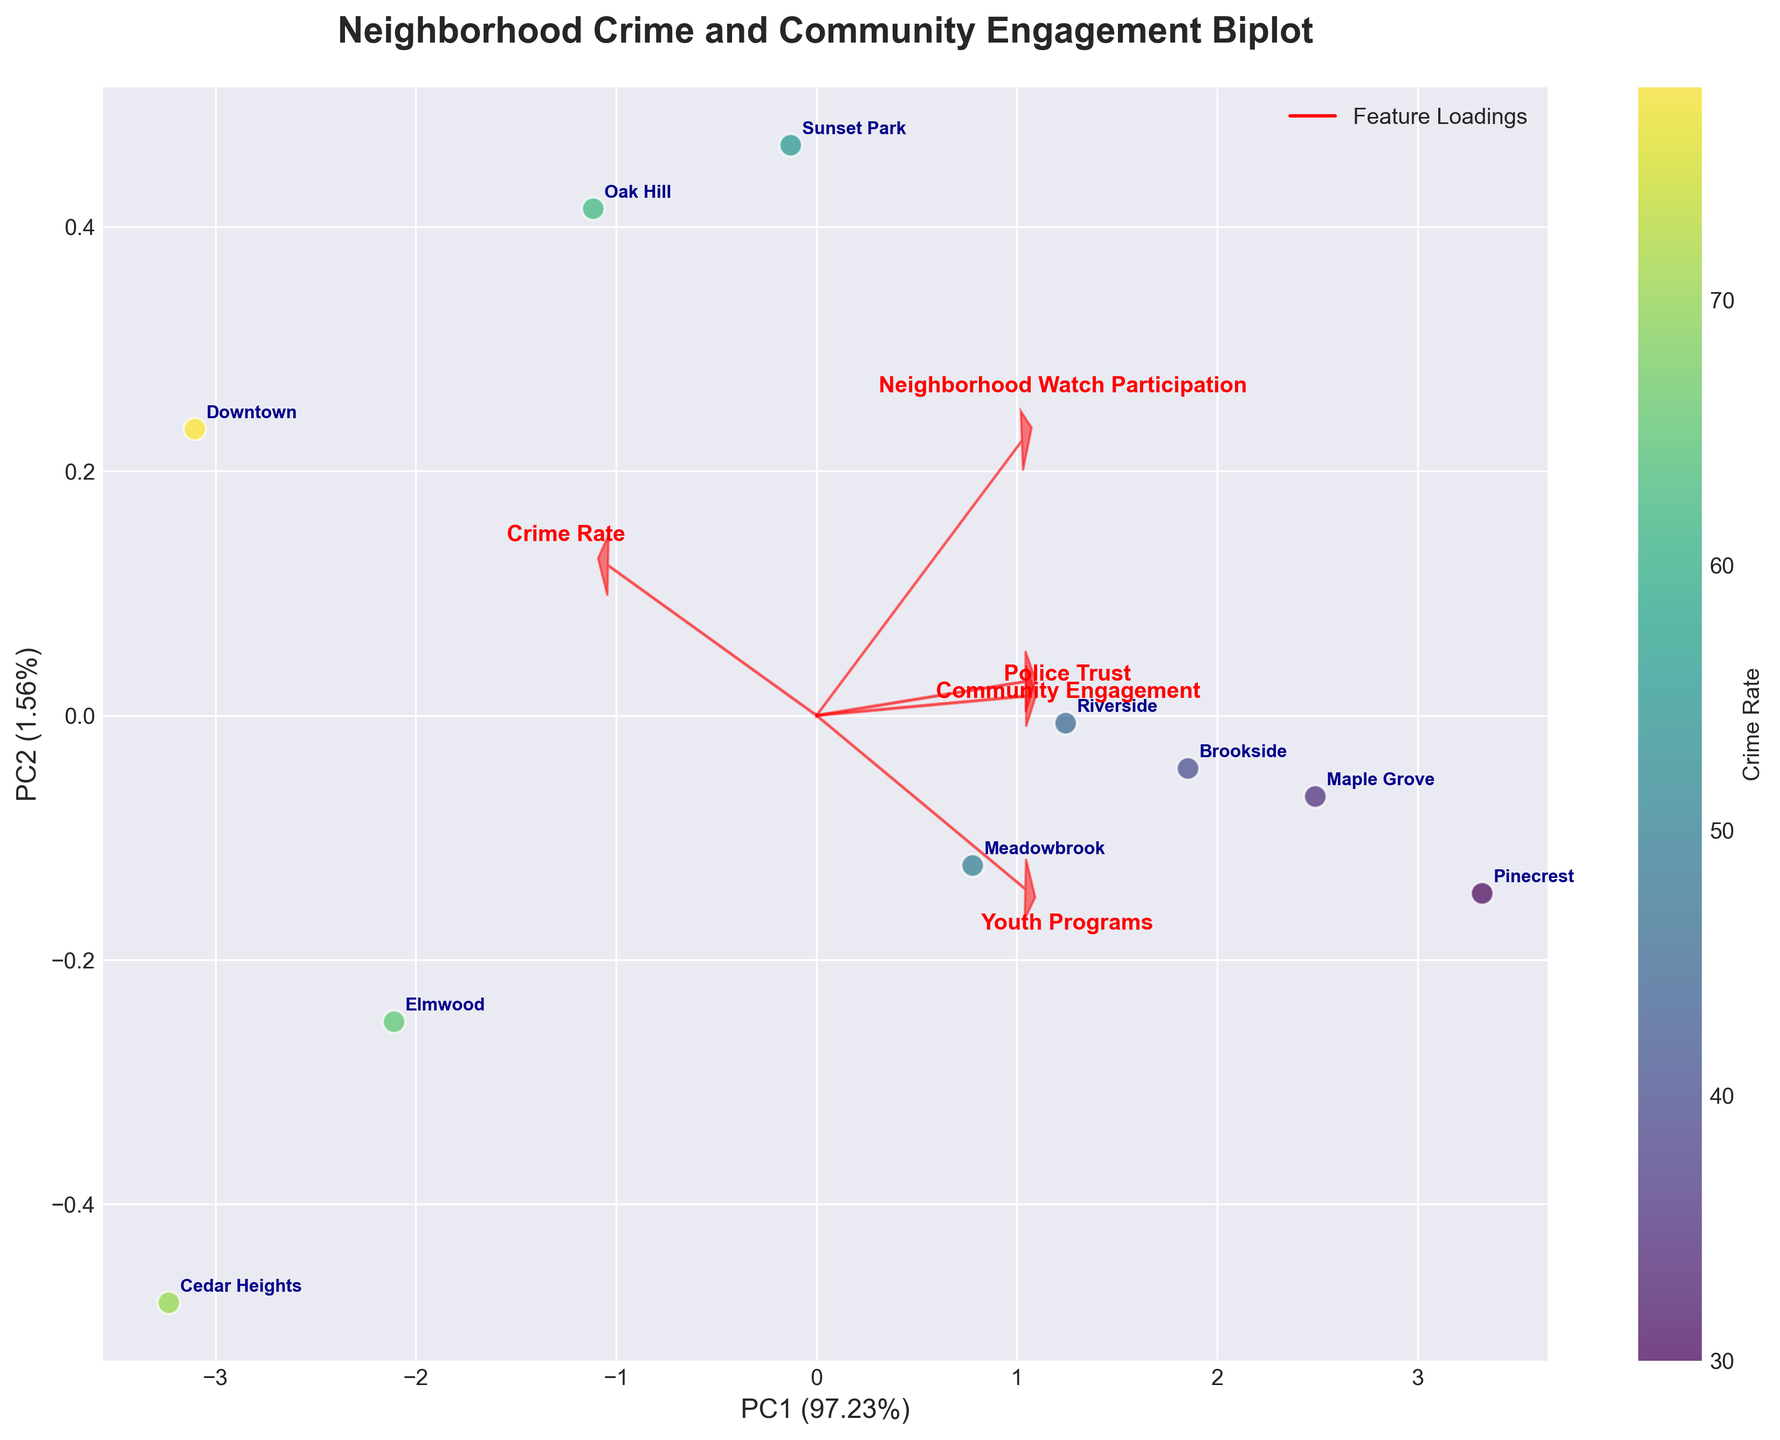What are the labels on the axes? The x-axis and y-axis labels are derived from the Principal Component Analysis (PCA). The x-axis label is "PC1" which represents the first principal component and it accounts for a specific percentage of the variance in the data. Similarly, the y-axis label is "PC2" representing the second principal component, which accounts for another specific percentage of the variance. These percentages are indicated next to the axis labels.
Answer: PC1 and PC2 What is the title of the plot? The title of the plot is indicated at the top of the figure in bold font. It describes the content and purpose of the plot. In this case, it reads "Neighborhood Crime and Community Engagement Biplot."
Answer: Neighborhood Crime and Community Engagement Biplot How many neighborhoods are represented in the plot? Each point in the plot represents a neighborhood. We count how many unique labels (neighborhood names) are annotated on the plot to determine the total number of neighborhoods.
Answer: 10 Which neighborhood has the highest crime rate? The color of the points represents the crime rate, with a color bar indicating the scale. By identifying the darkest colored point (closest to the highest value on the color bar), we can see which neighborhood it corresponds to. The annotation next to this point shows the neighborhood name.
Answer: Downtown Which two neighborhoods have the highest community engagement scores? The loadings related to "Community Engagement" arrow and the positions of the points help identify this. Look for neighborhoods closest to the arrowhead pointing towards high community engagement values. Additionally, cross-reference the scatter plot with the annotations to determine the names of the neighborhoods.
Answer: Pinecrest and Maple Grove Describe the relationship between "Youth Programs" and "Police Trust". To understand the relationship, observe the directions and lengths of the arrows for "Youth Programs" and "Police Trust." If the arrows point in a similar direction, it indicates a positive correlation. Conversely, if they point in opposite directions, it suggests a negative correlation.
Answer: Positive correlation Which neighborhood has the lowest community engagement and how is it indicated? Locate the point closest to the tail of the "Community Engagement" arrow. This point represents the neighborhood with the lowest community engagement score. The corresponding neighborhood name is annotated next to this point.
Answer: Cedar Heights How are the crime rate and neighborhood watch participation related? Examine the arrows for "Crime Rate" and "Neighborhood Watch Participation." Arrows pointing in similar directions indicate a positive correlation, while arrows pointing in opposite directions indicate a negative correlation.
Answer: Negative correlation What does a high PC1 score indicate? Since PC1 captures the largest variance in the data, the direction and magnitude of arrows help infer which features are contributing positively to PC1. Typically, large scores on PC1 are associated with features whose loadings point in the same direction and have large values.
Answer: High values in features with arrows pointing in the same direction as PC1 